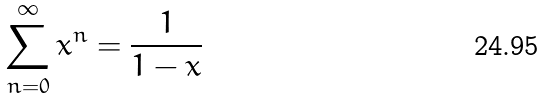<formula> <loc_0><loc_0><loc_500><loc_500>\sum _ { n = 0 } ^ { \infty } x ^ { n } = \frac { 1 } { 1 - x }</formula> 